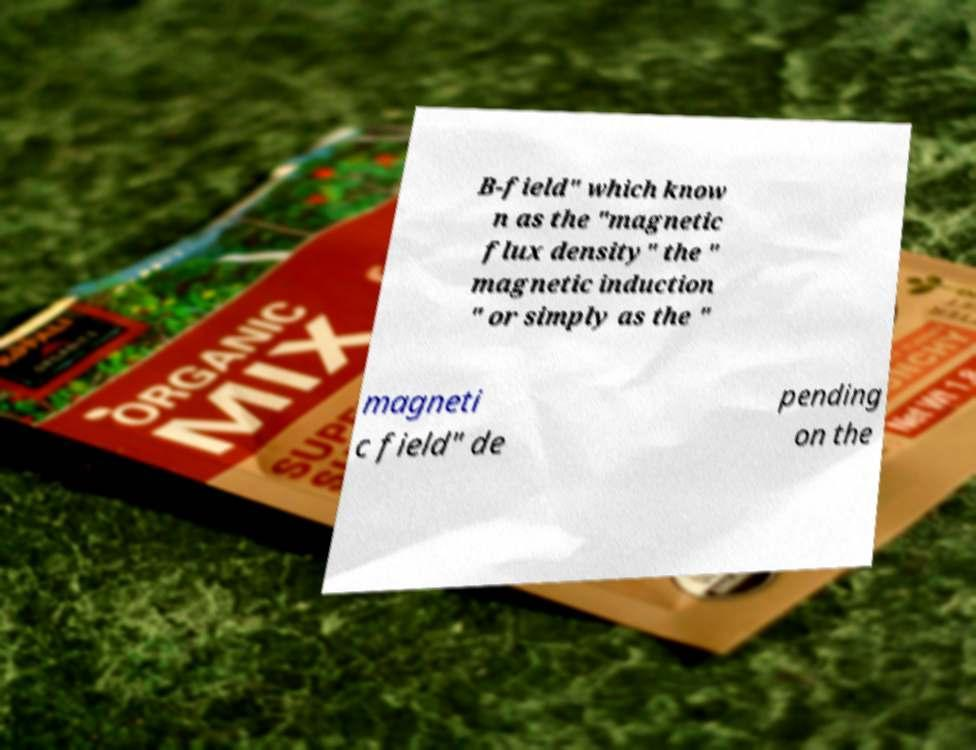What messages or text are displayed in this image? I need them in a readable, typed format. B-field" which know n as the "magnetic flux density" the " magnetic induction " or simply as the " magneti c field" de pending on the 